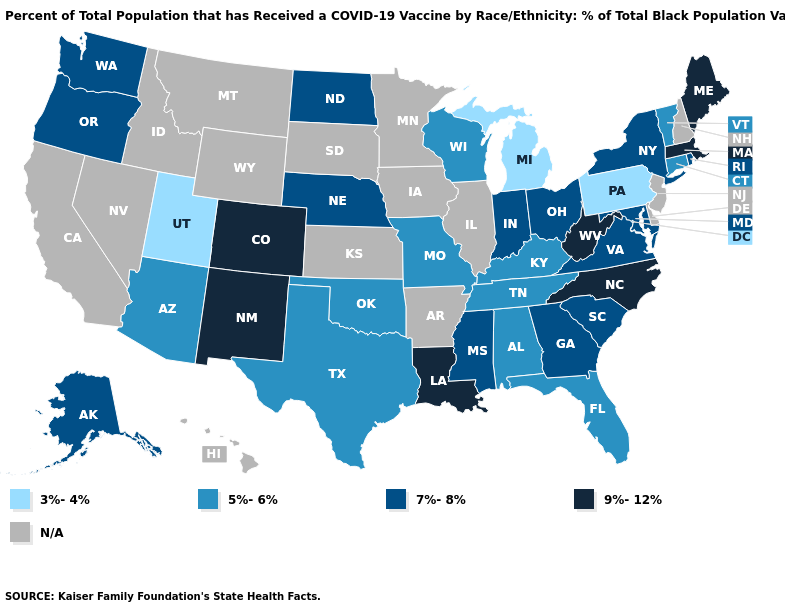What is the value of Texas?
Give a very brief answer. 5%-6%. Among the states that border New Jersey , does New York have the highest value?
Give a very brief answer. Yes. Which states hav the highest value in the South?
Be succinct. Louisiana, North Carolina, West Virginia. What is the lowest value in states that border California?
Give a very brief answer. 5%-6%. Does Massachusetts have the highest value in the Northeast?
Give a very brief answer. Yes. What is the lowest value in the Northeast?
Keep it brief. 3%-4%. Does the map have missing data?
Give a very brief answer. Yes. What is the value of Maryland?
Short answer required. 7%-8%. Name the states that have a value in the range 9%-12%?
Write a very short answer. Colorado, Louisiana, Maine, Massachusetts, New Mexico, North Carolina, West Virginia. Name the states that have a value in the range 3%-4%?
Write a very short answer. Michigan, Pennsylvania, Utah. Does North Carolina have the highest value in the South?
Concise answer only. Yes. Which states have the lowest value in the USA?
Short answer required. Michigan, Pennsylvania, Utah. Among the states that border Florida , does Georgia have the highest value?
Write a very short answer. Yes. What is the lowest value in the USA?
Be succinct. 3%-4%. Does New York have the lowest value in the Northeast?
Short answer required. No. 